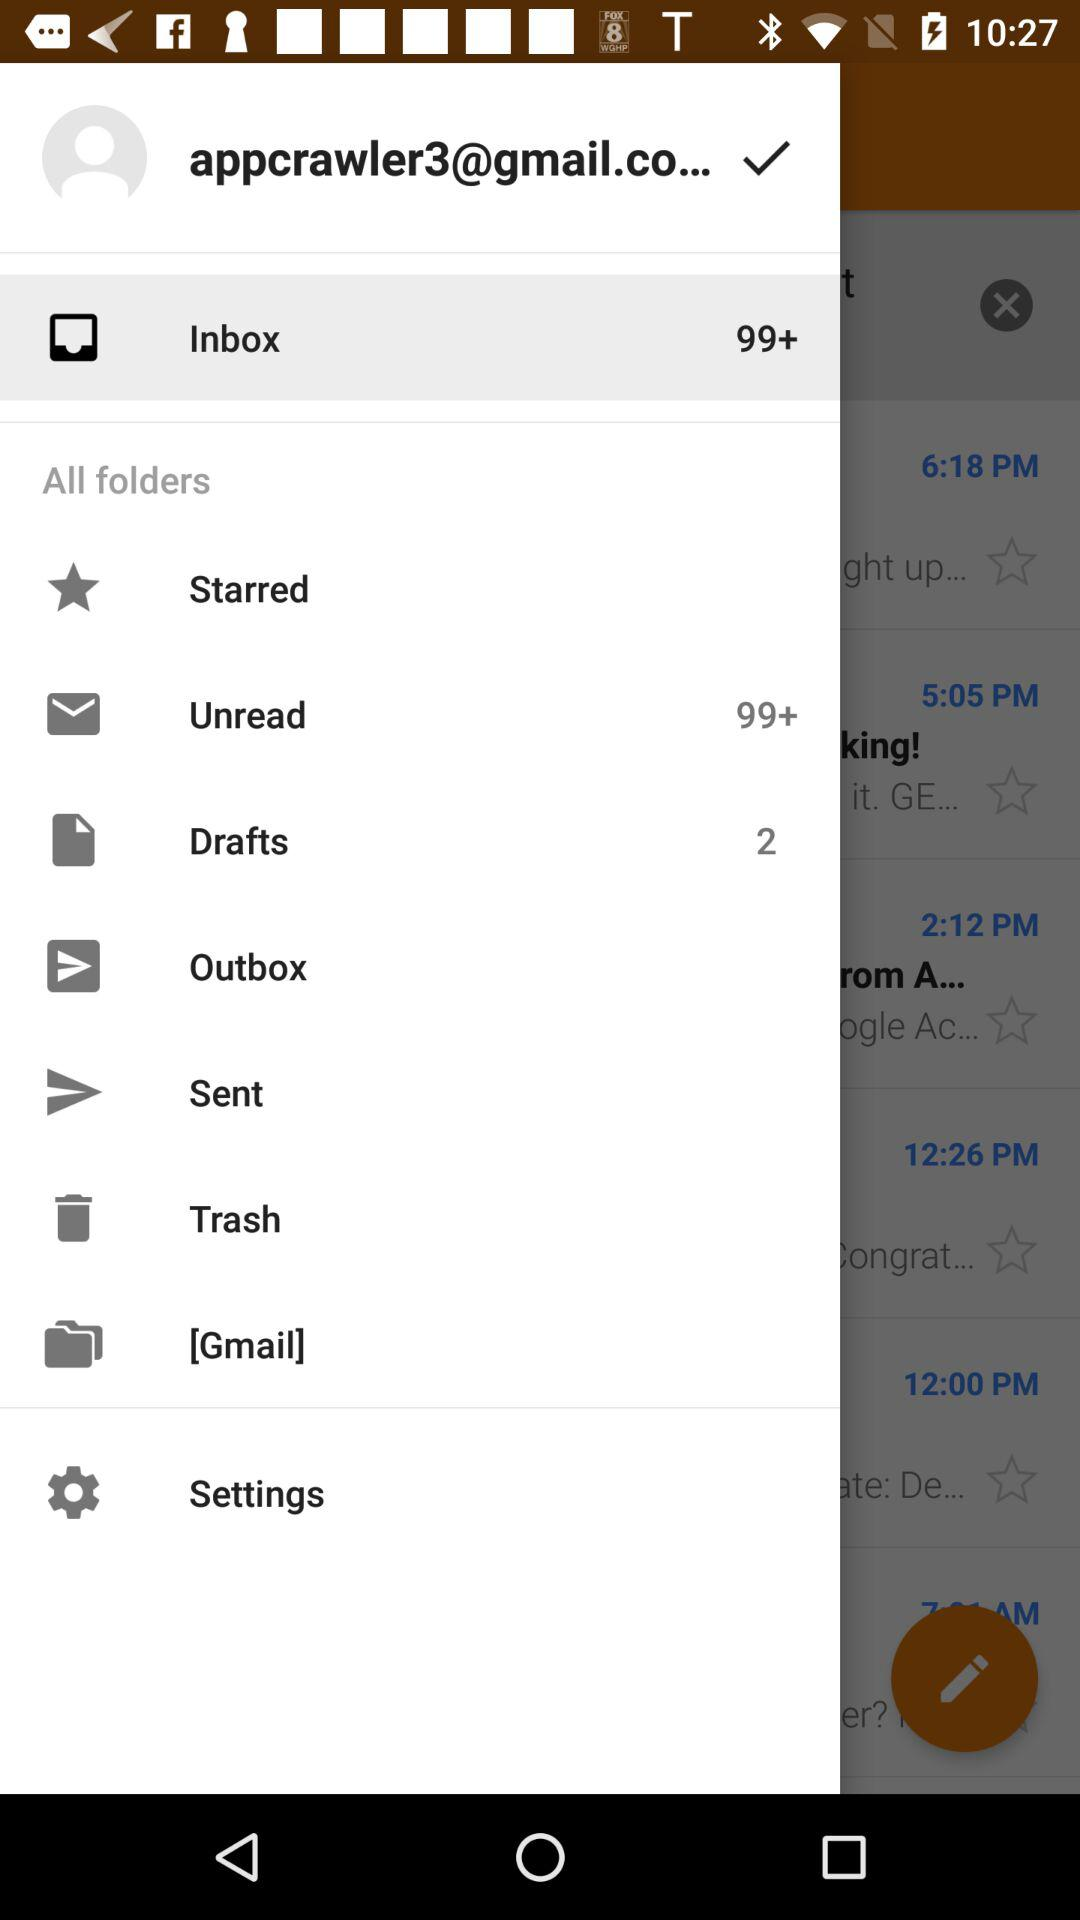How many mails are in "Drafts"? There are 2 mails in "Drafts". 